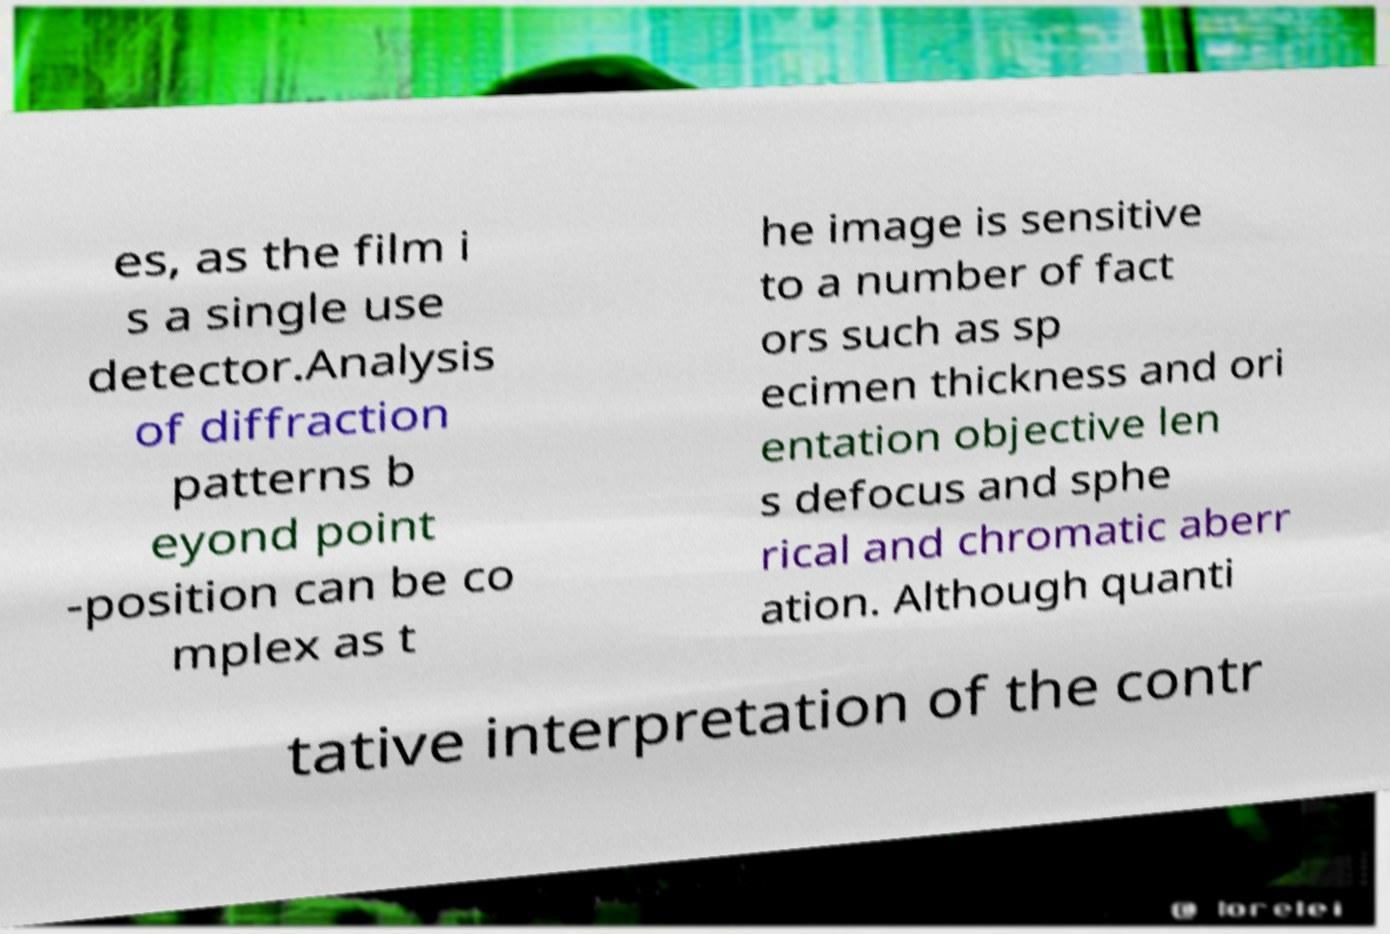I need the written content from this picture converted into text. Can you do that? es, as the film i s a single use detector.Analysis of diffraction patterns b eyond point -position can be co mplex as t he image is sensitive to a number of fact ors such as sp ecimen thickness and ori entation objective len s defocus and sphe rical and chromatic aberr ation. Although quanti tative interpretation of the contr 